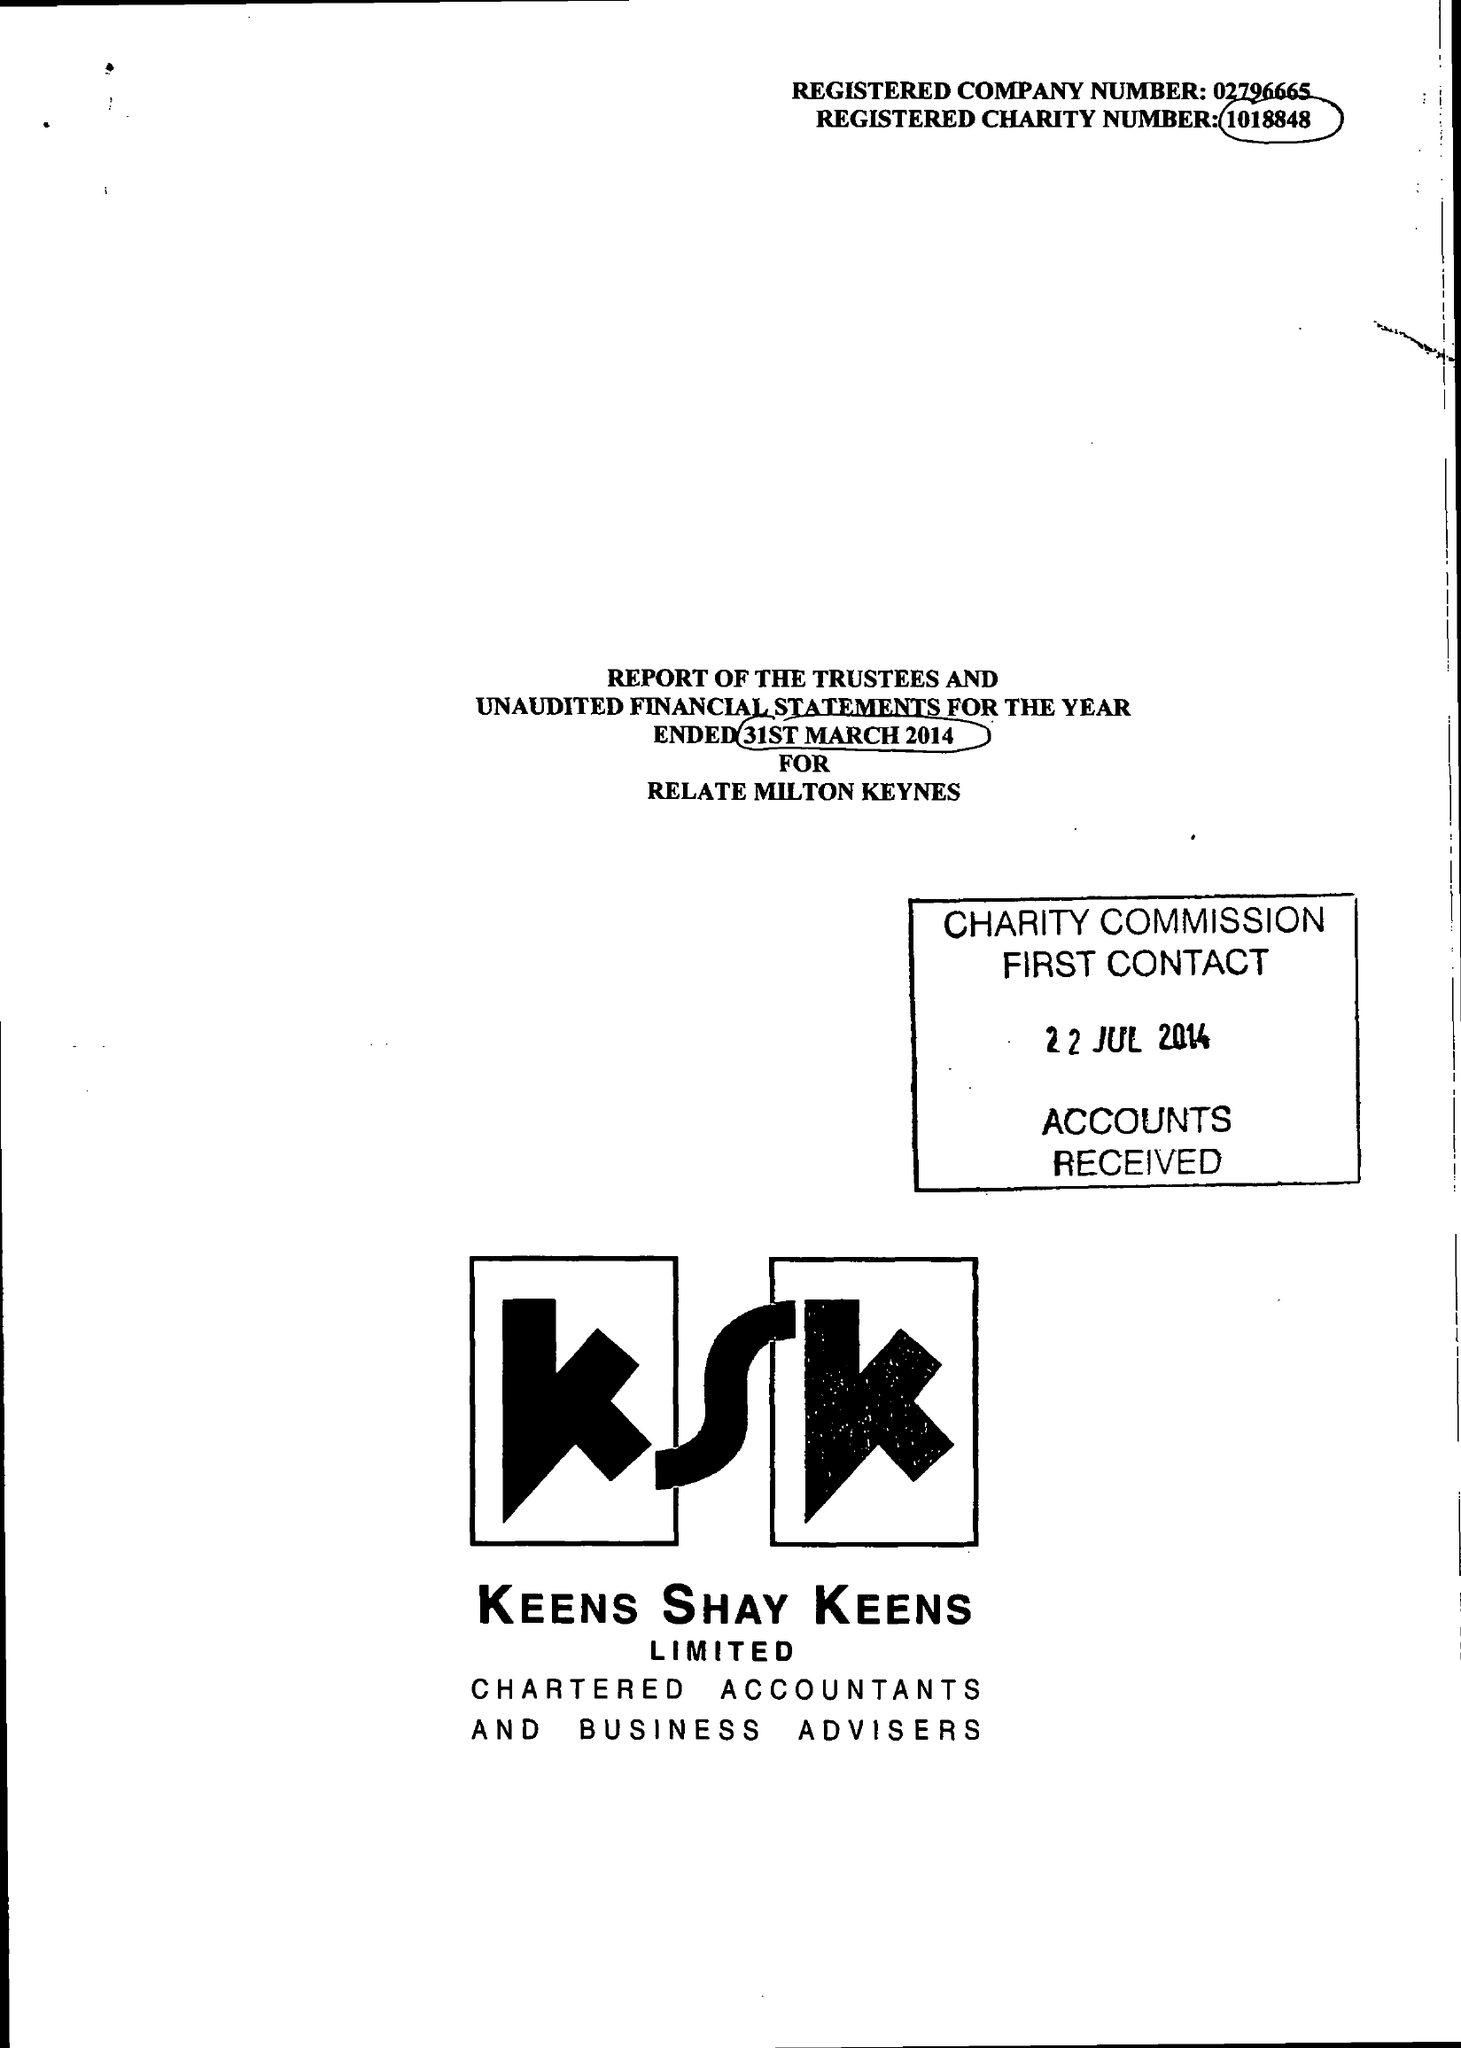What is the value for the address__street_line?
Answer the question using a single word or phrase. 47 AYLESBURY STREET 